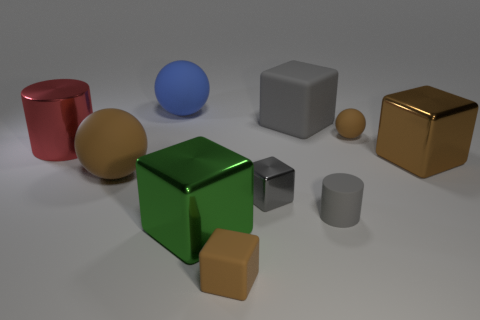Subtract all blue spheres. How many spheres are left? 2 Subtract all small matte cubes. How many cubes are left? 4 Subtract all cylinders. How many objects are left? 8 Subtract all gray cylinders. Subtract all purple balls. How many cylinders are left? 1 Subtract all green cubes. How many gray cylinders are left? 1 Subtract all large red cylinders. Subtract all big gray cubes. How many objects are left? 8 Add 6 red metal things. How many red metal things are left? 7 Add 6 small green matte blocks. How many small green matte blocks exist? 6 Subtract 0 blue blocks. How many objects are left? 10 Subtract 2 cylinders. How many cylinders are left? 0 